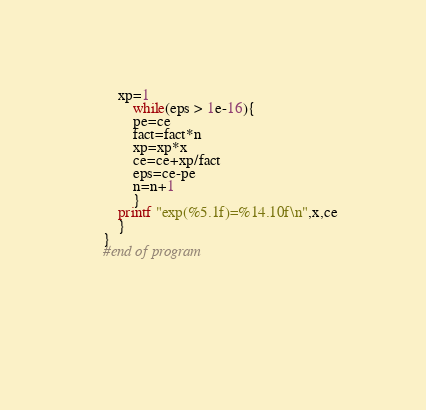<code> <loc_0><loc_0><loc_500><loc_500><_Awk_>		xp=1
			while(eps > 1e-16){
			pe=ce
			fact=fact*n
			xp=xp*x
			ce=ce+xp/fact
			eps=ce-pe
			n=n+1
			}
		printf "exp(%5.1f)=%14.10f\n",x,ce
		}
	}
	#end of program




	
</code> 